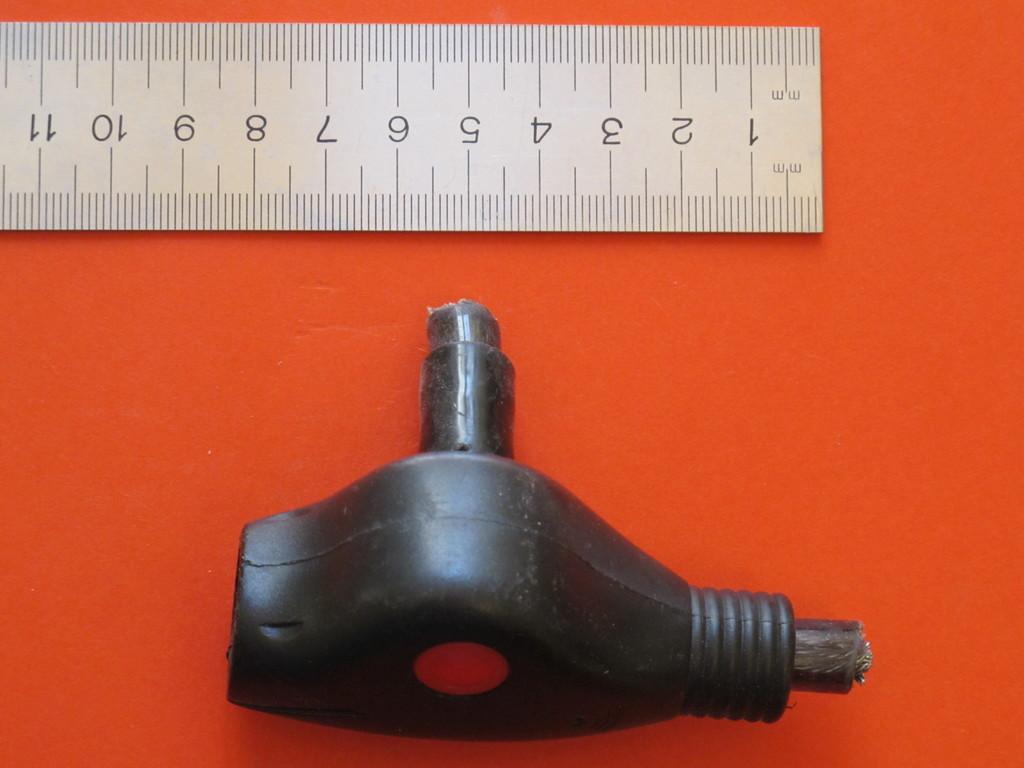What is the longest this ruler can measure?
Offer a terse response. Unanswerable. Which unit of measurement does the ruler use?
Your answer should be very brief. Mm. 